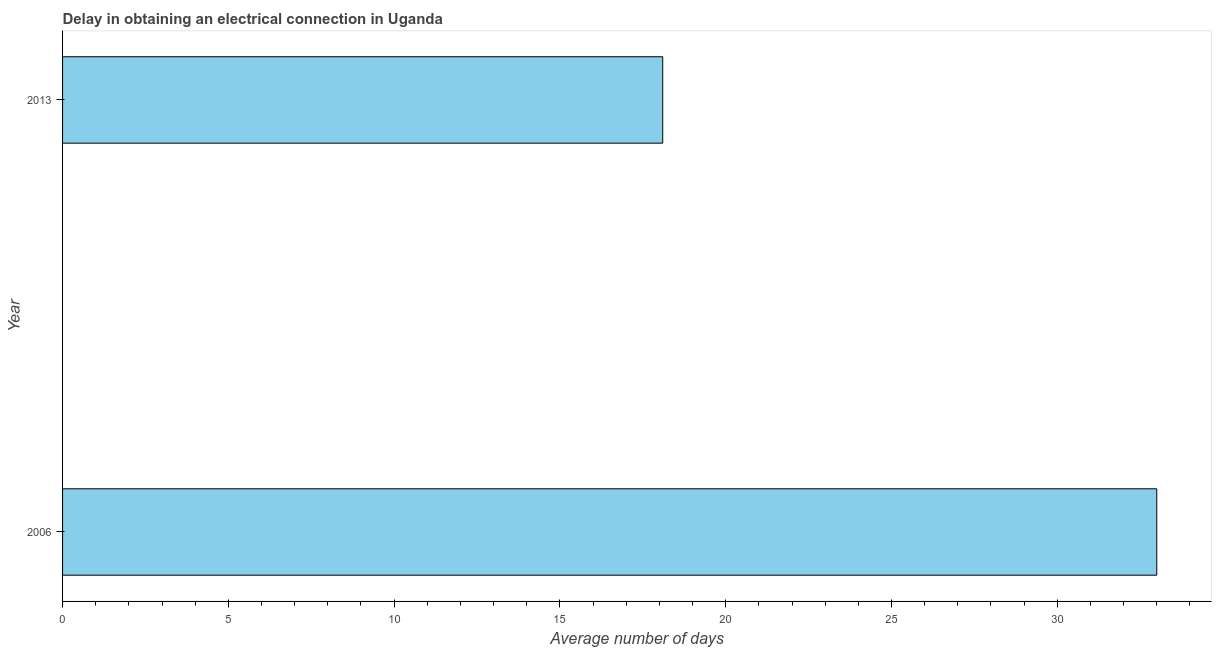What is the title of the graph?
Offer a terse response. Delay in obtaining an electrical connection in Uganda. What is the label or title of the X-axis?
Offer a terse response. Average number of days. Across all years, what is the minimum dalay in electrical connection?
Your response must be concise. 18.1. In which year was the dalay in electrical connection maximum?
Offer a very short reply. 2006. What is the sum of the dalay in electrical connection?
Your response must be concise. 51.1. What is the average dalay in electrical connection per year?
Make the answer very short. 25.55. What is the median dalay in electrical connection?
Your response must be concise. 25.55. In how many years, is the dalay in electrical connection greater than 32 days?
Your answer should be compact. 1. What is the ratio of the dalay in electrical connection in 2006 to that in 2013?
Your answer should be very brief. 1.82. In how many years, is the dalay in electrical connection greater than the average dalay in electrical connection taken over all years?
Give a very brief answer. 1. Are all the bars in the graph horizontal?
Offer a terse response. Yes. How many years are there in the graph?
Your answer should be very brief. 2. What is the difference between two consecutive major ticks on the X-axis?
Make the answer very short. 5. Are the values on the major ticks of X-axis written in scientific E-notation?
Your response must be concise. No. What is the Average number of days of 2006?
Your response must be concise. 33. What is the difference between the Average number of days in 2006 and 2013?
Your answer should be compact. 14.9. What is the ratio of the Average number of days in 2006 to that in 2013?
Provide a succinct answer. 1.82. 